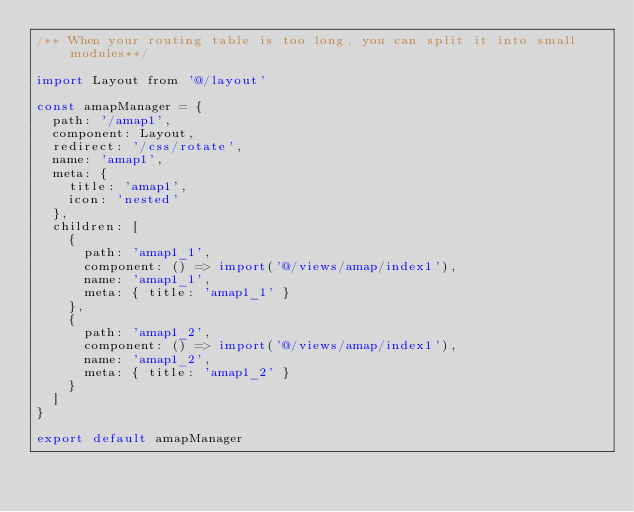<code> <loc_0><loc_0><loc_500><loc_500><_JavaScript_>/** When your routing table is too long, you can split it into small modules**/

import Layout from '@/layout'

const amapManager = {
  path: '/amap1',
  component: Layout,
  redirect: '/css/rotate',
  name: 'amap1',
  meta: {
    title: 'amap1',
    icon: 'nested'
  },
  children: [
    {
      path: 'amap1_1',
      component: () => import('@/views/amap/index1'),
      name: 'amap1_1',
      meta: { title: 'amap1_1' }
    },
    {
      path: 'amap1_2',
      component: () => import('@/views/amap/index1'),
      name: 'amap1_2',
      meta: { title: 'amap1_2' }
    }
  ]
}

export default amapManager
</code> 